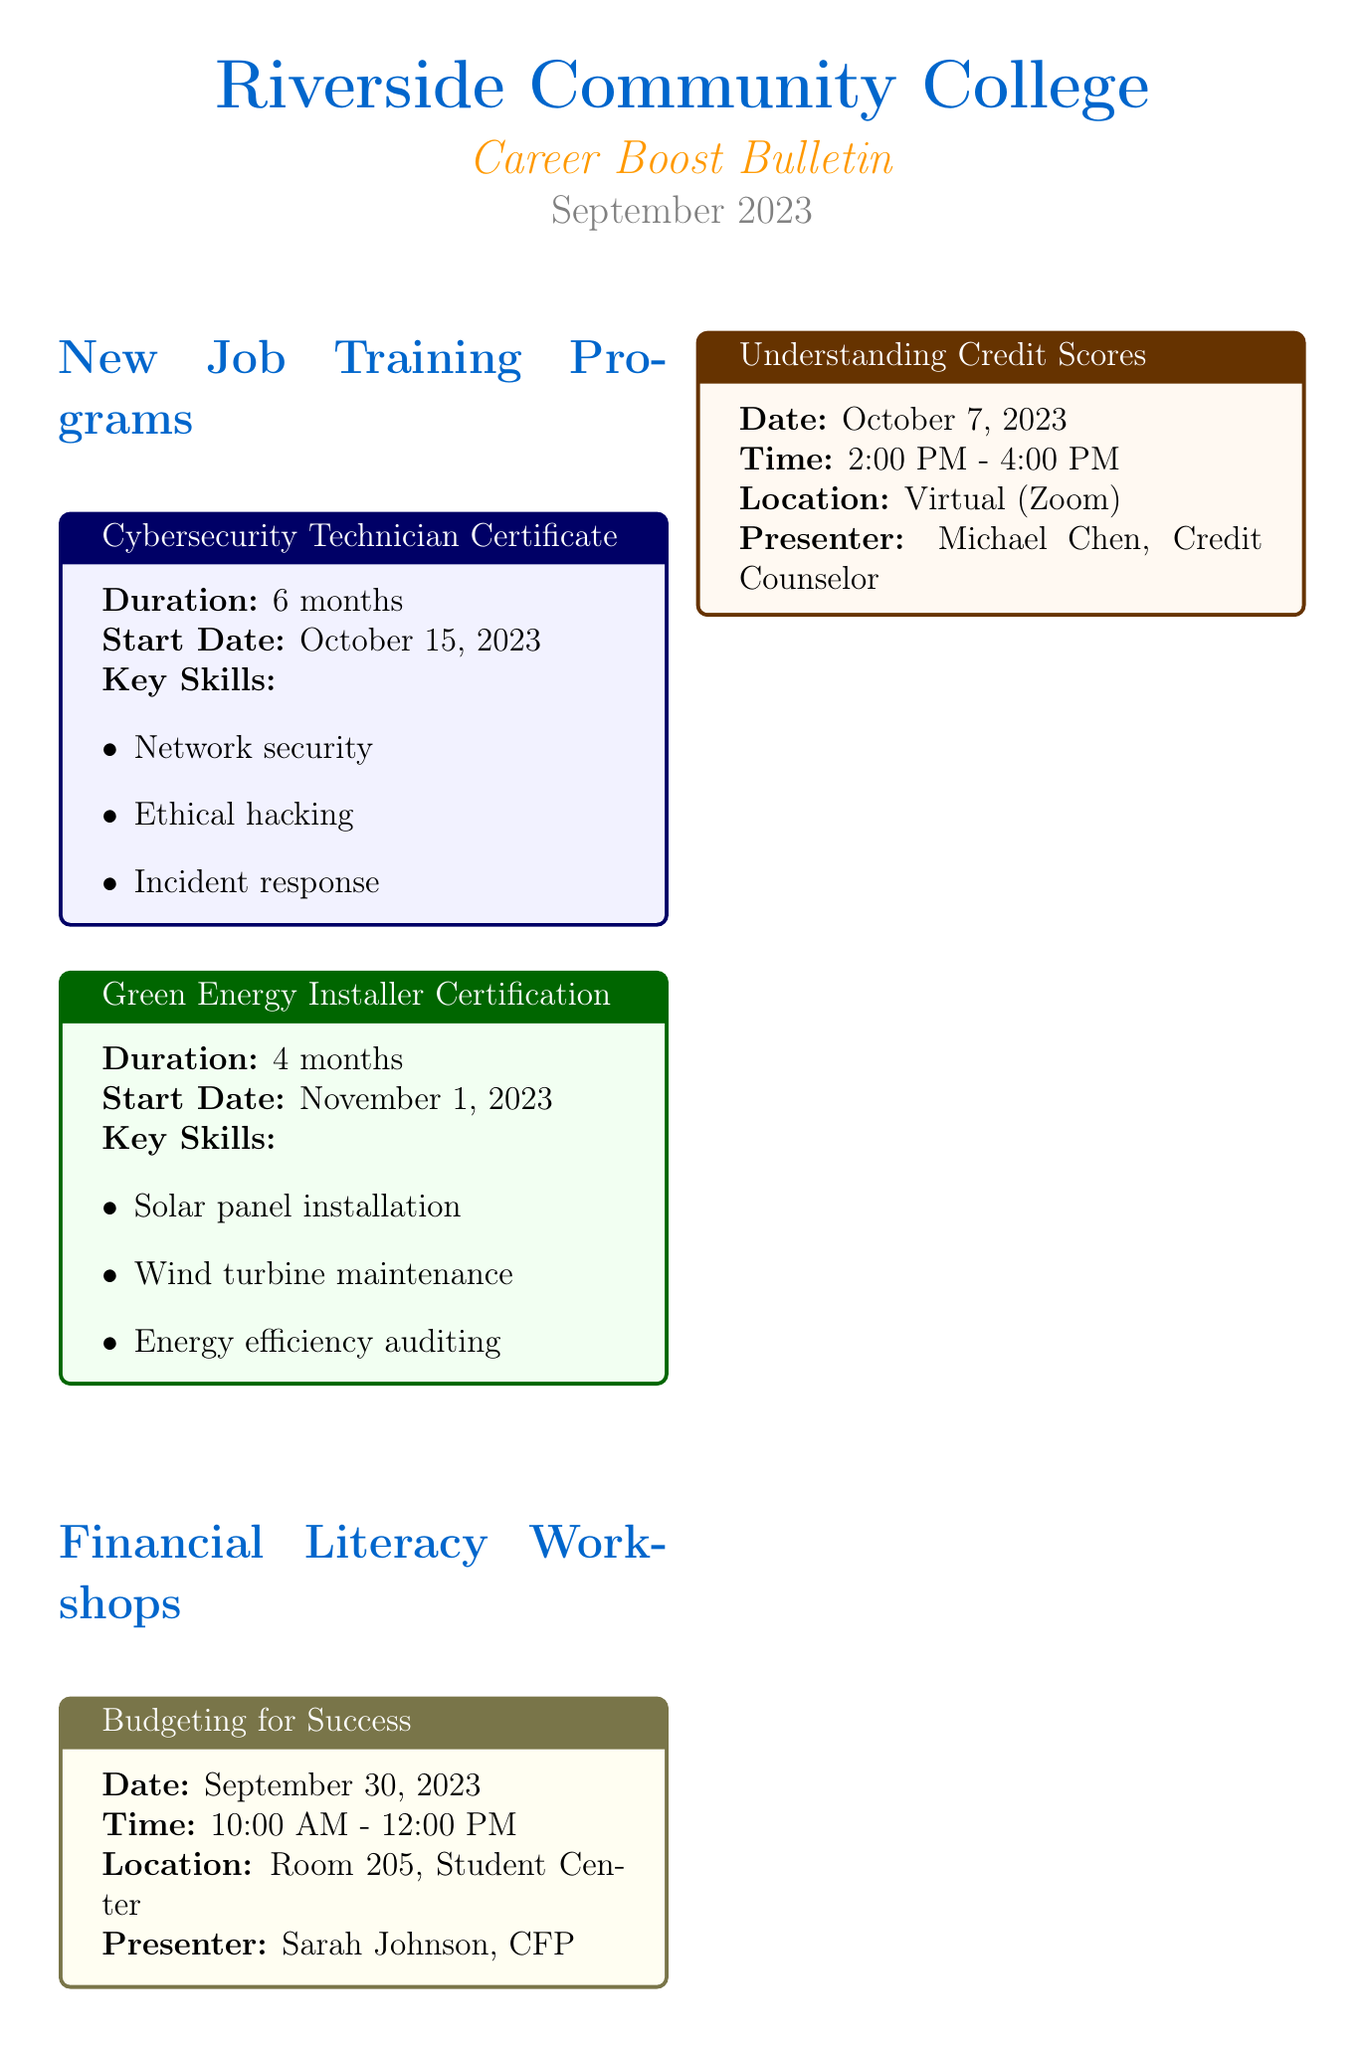What is the title of the newsletter? The title of the newsletter is explicitly mentioned in the header of the document as "Career Boost Bulletin."
Answer: Career Boost Bulletin When does the Cybersecurity Technician Certificate program start? The start date for this program is provided in the document, which is October 15, 2023.
Answer: October 15, 2023 Who is the presenter for the "Understanding Credit Scores" workshop? The document mentions the presenter's name associated with this workshop, which is Michael Chen.
Answer: Michael Chen What is the duration of the Green Energy Installer Certification program? The duration is specified in the document as 4 months.
Answer: 4 months What is the current job of Emily Rodriguez? The document presents her job title after completing the program, which is Medical Records Specialist.
Answer: Medical Records Specialist How many financial literacy workshops are listed in the document? The document lists two workshops, focusing on financial literacy, explicitly mentioned in the Financial Literacy Workshops section.
Answer: 2 What date is the "Budgeting for Success" workshop scheduled? The date for this particular workshop is provided in the document as September 30, 2023.
Answer: September 30, 2023 How can individuals contact the career services? The document includes contact information for career services, providing a phone number and an email address.
Answer: (555) 123-4567 and careerservices@riverside.edu 